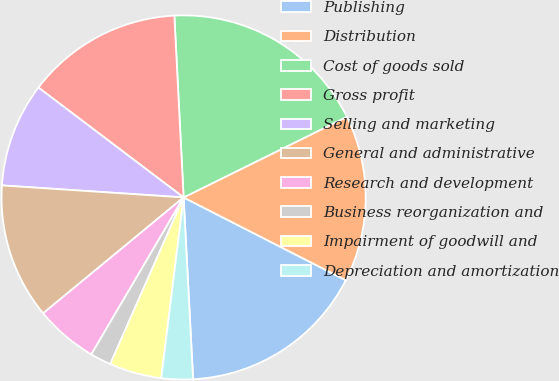Convert chart to OTSL. <chart><loc_0><loc_0><loc_500><loc_500><pie_chart><fcel>Publishing<fcel>Distribution<fcel>Cost of goods sold<fcel>Gross profit<fcel>Selling and marketing<fcel>General and administrative<fcel>Research and development<fcel>Business reorganization and<fcel>Impairment of goodwill and<fcel>Depreciation and amortization<nl><fcel>16.66%<fcel>14.81%<fcel>18.51%<fcel>13.88%<fcel>9.26%<fcel>12.03%<fcel>5.56%<fcel>1.86%<fcel>4.64%<fcel>2.79%<nl></chart> 